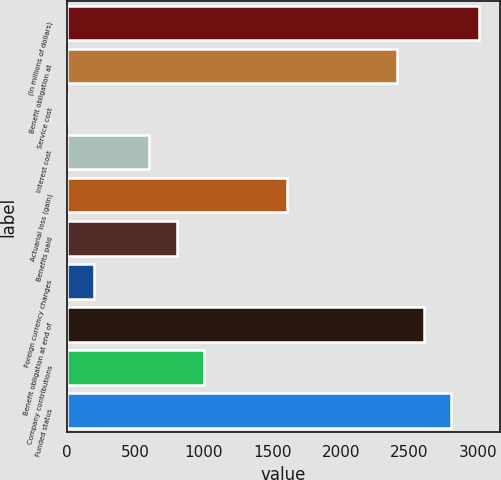Convert chart. <chart><loc_0><loc_0><loc_500><loc_500><bar_chart><fcel>(In millions of dollars)<fcel>Benefit obligation at<fcel>Service cost<fcel>Interest cost<fcel>Actuarial loss (gain)<fcel>Benefits paid<fcel>Foreign currency changes<fcel>Benefit obligation at end of<fcel>Company contributions<fcel>Funded status<nl><fcel>3007<fcel>2405.8<fcel>1<fcel>602.2<fcel>1604.2<fcel>802.6<fcel>201.4<fcel>2606.2<fcel>1003<fcel>2806.6<nl></chart> 